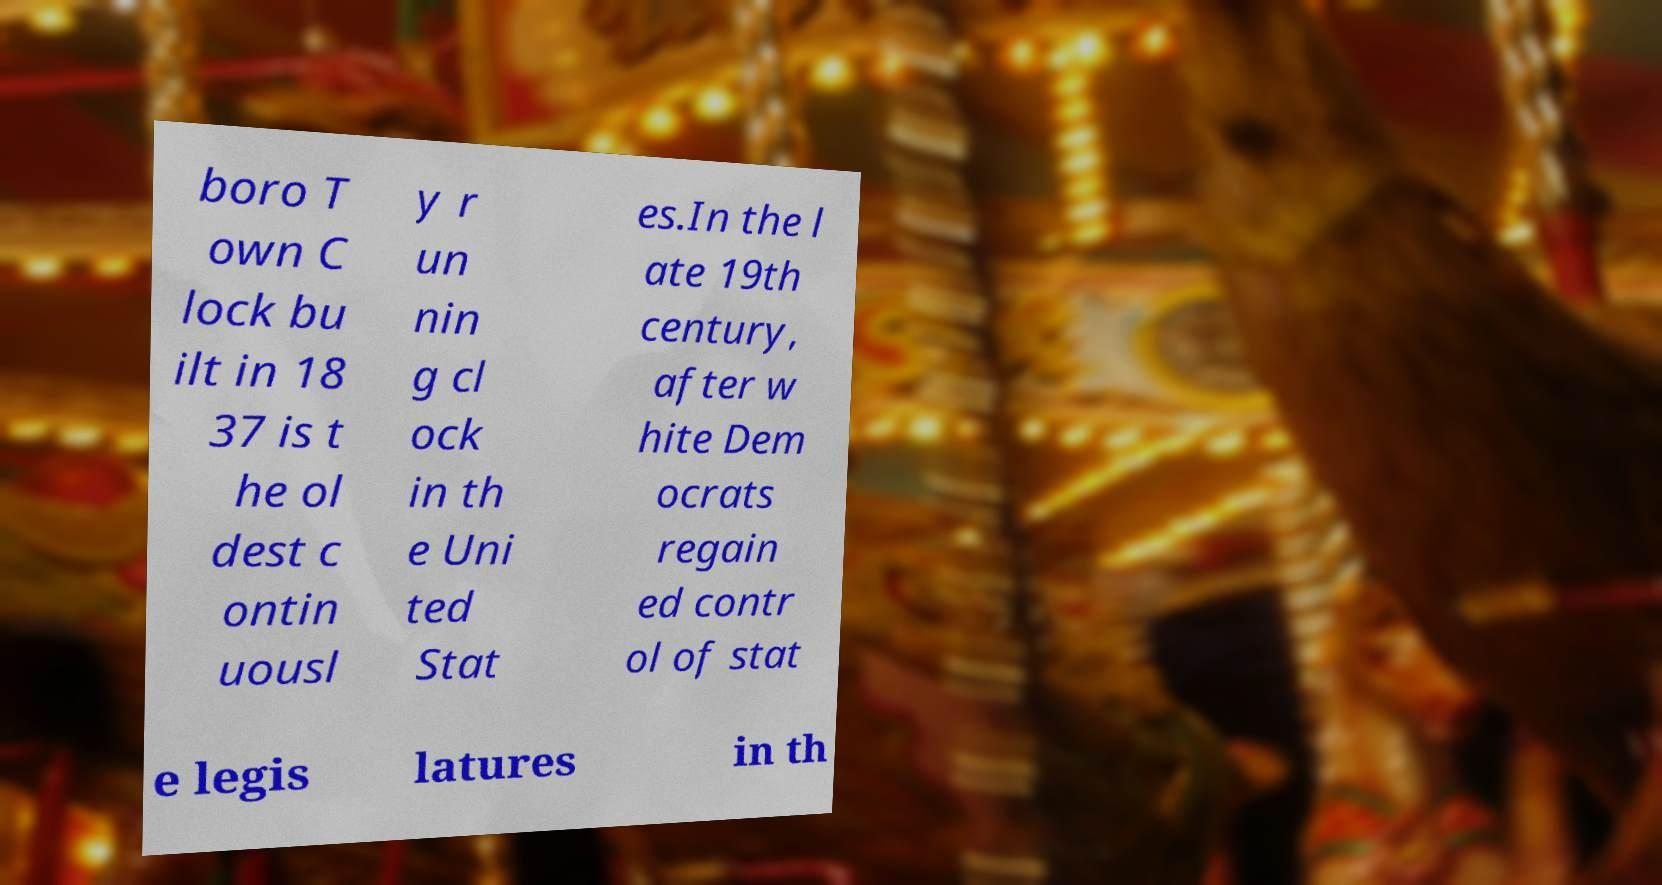Can you read and provide the text displayed in the image?This photo seems to have some interesting text. Can you extract and type it out for me? boro T own C lock bu ilt in 18 37 is t he ol dest c ontin uousl y r un nin g cl ock in th e Uni ted Stat es.In the l ate 19th century, after w hite Dem ocrats regain ed contr ol of stat e legis latures in th 